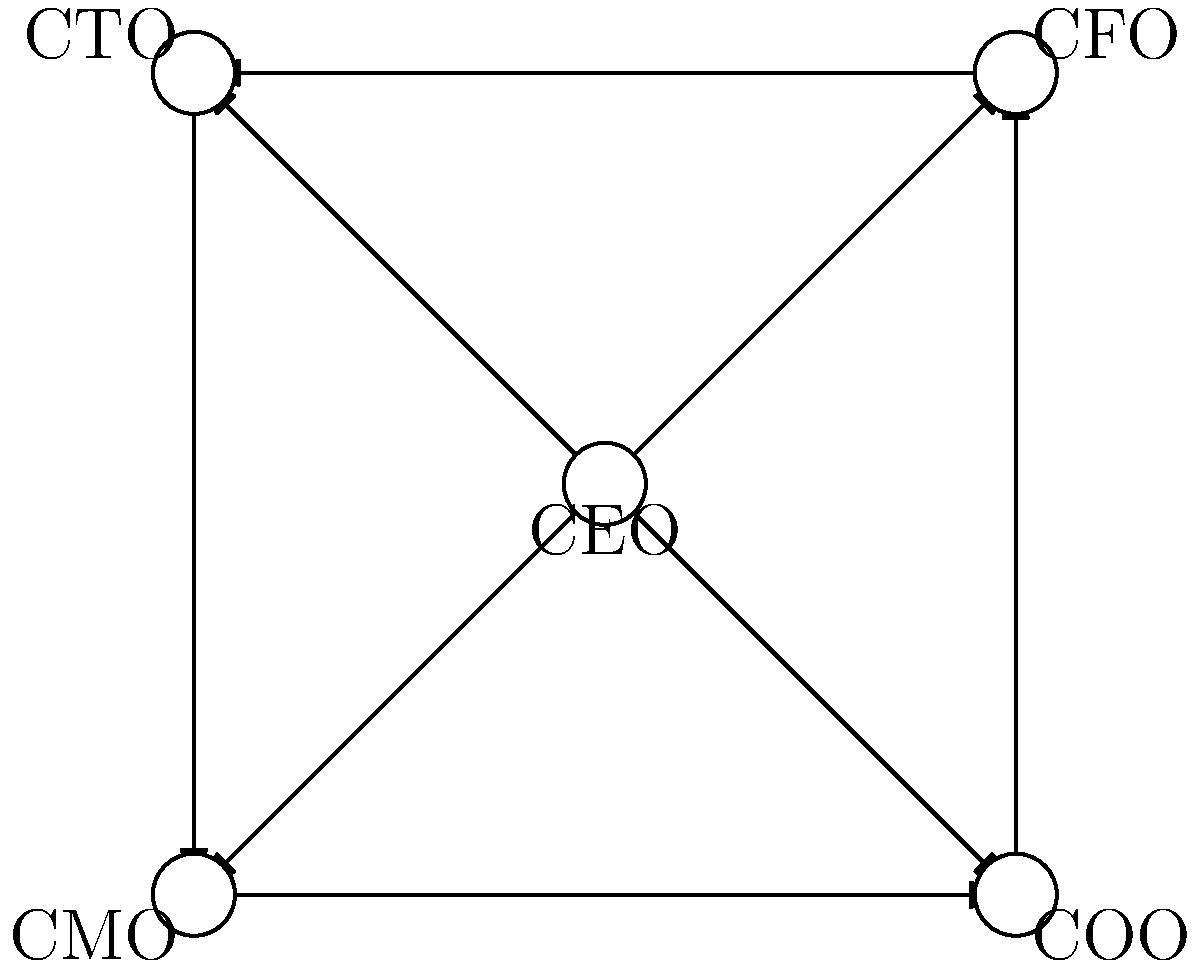As a successful entrepreneur leading a diverse team, you want to visualize the structure of your executive team using a Cayley graph. The graph represents the communication channels between team members, where each edge represents a direct line of communication. Given the Cayley graph above, what is the minimum number of communication steps required for information to flow from the CEO to all other team members? To determine the minimum number of communication steps, we need to analyze the structure of the Cayley graph:

1. The CEO is at the center of the graph, directly connected to all other team members (CFO, CTO, CMO, and COO).

2. Each edge in the graph represents a direct communication channel between two team members.

3. The CEO can reach any team member in a single step due to the direct connections.

4. Since the question asks for the minimum number of steps for information to flow from the CEO to all other team members, we need to consider the most efficient way to disseminate information.

5. In this case, the CEO can simultaneously communicate with all four other team members in a single step.

6. There's no need for multiple steps or relay communication through other team members, as the CEO has direct access to everyone.

Therefore, the minimum number of communication steps required for information to flow from the CEO to all other team members is 1.

This efficient communication structure reflects a flat organizational hierarchy, which is often associated with agile and innovative companies, aligning well with the entrepreneurial mindset.
Answer: 1 step 